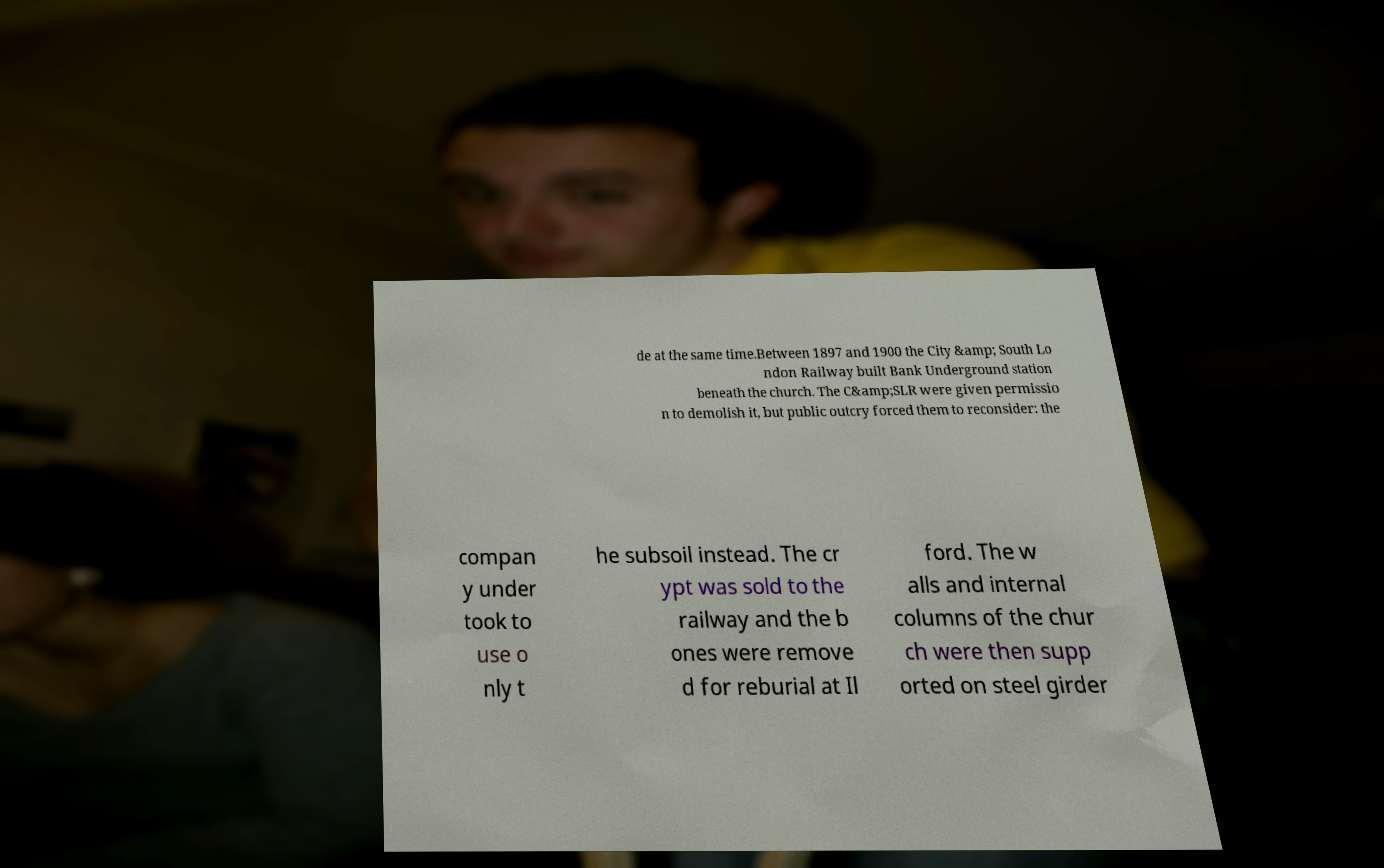Could you assist in decoding the text presented in this image and type it out clearly? de at the same time.Between 1897 and 1900 the City &amp; South Lo ndon Railway built Bank Underground station beneath the church. The C&amp;SLR were given permissio n to demolish it, but public outcry forced them to reconsider: the compan y under took to use o nly t he subsoil instead. The cr ypt was sold to the railway and the b ones were remove d for reburial at Il ford. The w alls and internal columns of the chur ch were then supp orted on steel girder 